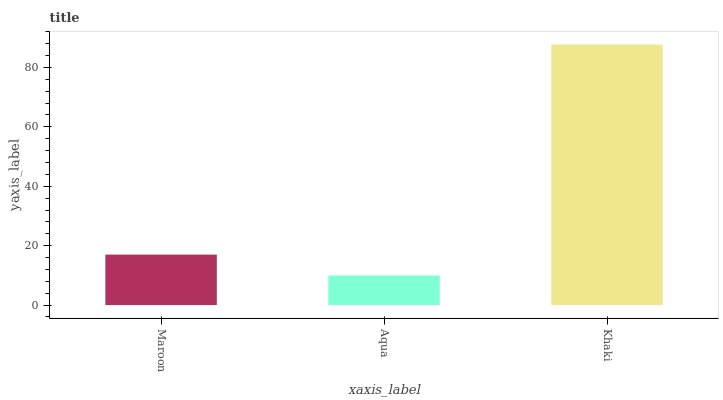Is Khaki the minimum?
Answer yes or no. No. Is Aqua the maximum?
Answer yes or no. No. Is Khaki greater than Aqua?
Answer yes or no. Yes. Is Aqua less than Khaki?
Answer yes or no. Yes. Is Aqua greater than Khaki?
Answer yes or no. No. Is Khaki less than Aqua?
Answer yes or no. No. Is Maroon the high median?
Answer yes or no. Yes. Is Maroon the low median?
Answer yes or no. Yes. Is Khaki the high median?
Answer yes or no. No. Is Aqua the low median?
Answer yes or no. No. 